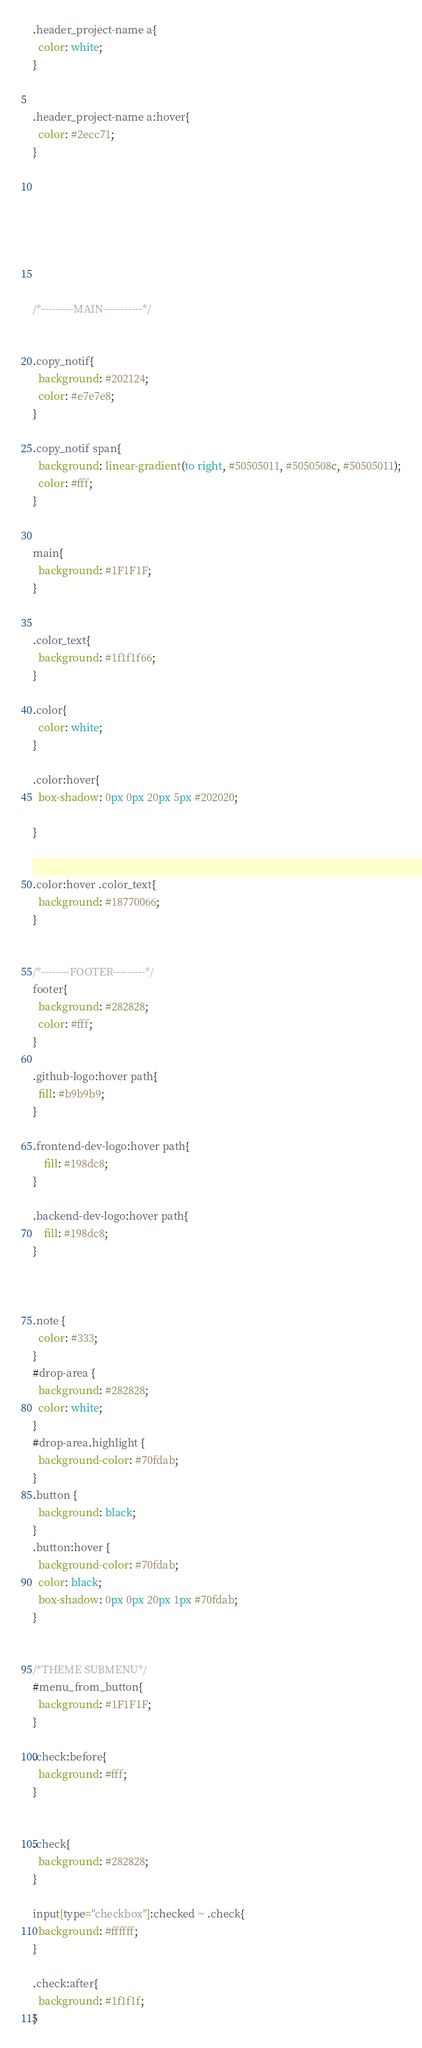Convert code to text. <code><loc_0><loc_0><loc_500><loc_500><_CSS_>.header_project-name a{
  color: white;
}


.header_project-name a:hover{
  color: #2ecc71;
}








/*---------MAIN-----------*/


.copy_notif{
  background: #202124;
  color: #e7e7e8;
}

.copy_notif span{
  background: linear-gradient(to right, #50505011, #5050508c, #50505011);
  color: #fff;
}


main{
  background: #1F1F1F;
}


.color_text{
  background: #1f1f1f66;
}

.color{
  color: white;
}

.color:hover{
  box-shadow: 0px 0px 20px 5px #202020;
  
}


.color:hover .color_text{
  background: #18770066;
}


/*--------FOOTER---------*/
footer{
  background: #282828; 
  color: #fff;
}

.github-logo:hover path{
  fill: #b9b9b9;
}

.frontend-dev-logo:hover path{
    fill: #198dc8;
}

.backend-dev-logo:hover path{
    fill: #198dc8;
}



.note {
  color: #333;
}
#drop-area {
  background: #282828;
  color: white;
}
#drop-area.highlight {
  background-color: #70fdab;
}
.button {
  background: black;
}
.button:hover {
  background-color: #70fdab;
  color: black;
  box-shadow: 0px 0px 20px 1px #70fdab;
}


/*THEME SUBMENU*/
#menu_from_button{
  background: #1F1F1F;
}

.check:before{
  background: #fff;
}


.check{
  background: #282828;
}

input[type="checkbox"]:checked ~ .check{
  background: #ffffff;
}

.check:after{
  background: #1f1f1f;
}</code> 